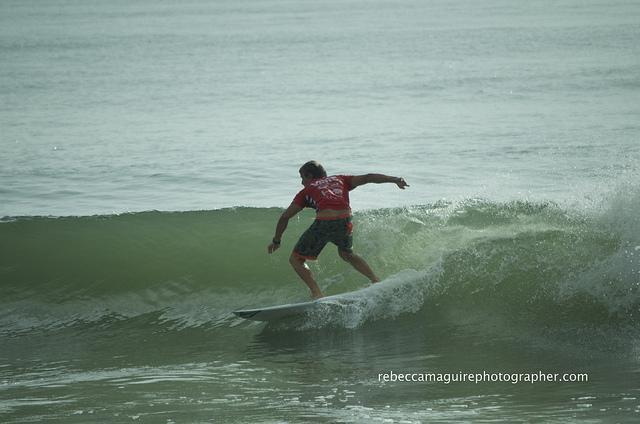How many people are in this picture?
Give a very brief answer. 1. How many purple suitcases are in the image?
Give a very brief answer. 0. 